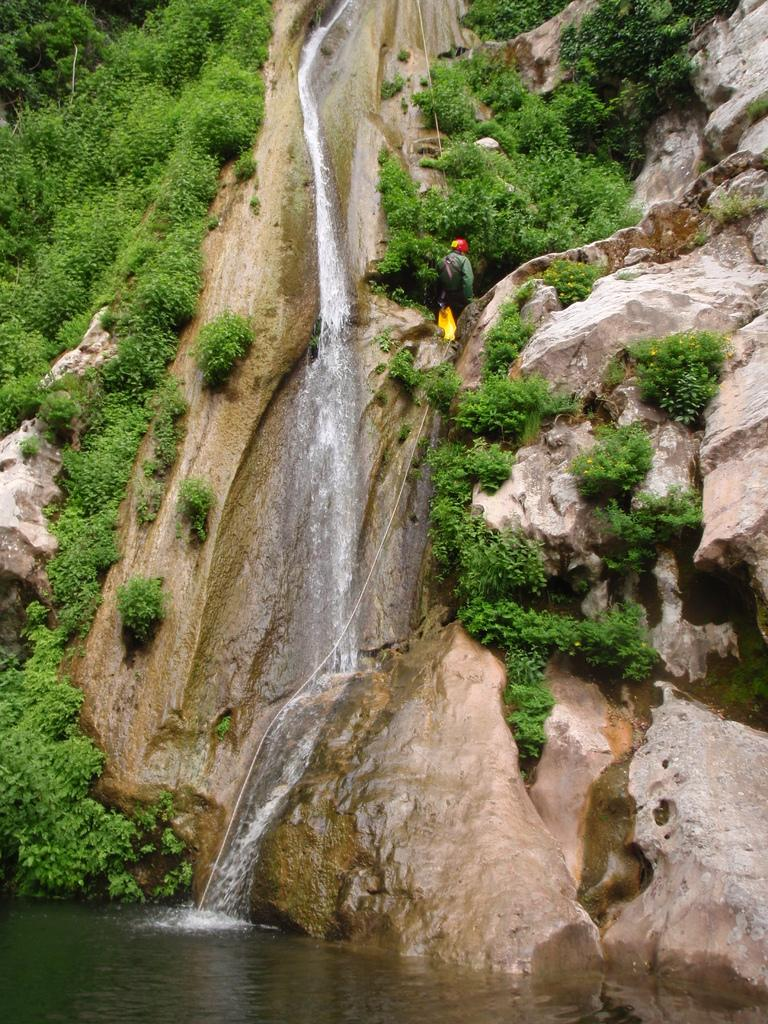What is the main subject of the image? The main subject of the image is a waterfall. What is happening to the water in the image? There is water flowing down from the waterfall. What can be seen on the hill near the waterfall? There are trees on the hill near the waterfall. What type of popcorn is being served at the waterfall in the image? There is no popcorn present in the image; it depicts a waterfall with water flowing down and trees on the hill. 